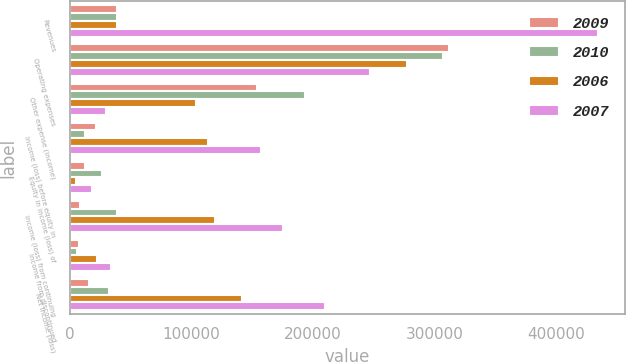<chart> <loc_0><loc_0><loc_500><loc_500><stacked_bar_chart><ecel><fcel>Revenues<fcel>Operating expenses<fcel>Other expense (income)<fcel>Income (loss) before equity in<fcel>Equity in income (loss) of<fcel>Income (loss) from continuing<fcel>Income from discontinued<fcel>Net income (loss)<nl><fcel>2009<fcel>38917<fcel>311622<fcel>153733<fcel>21451<fcel>12884<fcel>8567<fcel>7632<fcel>16199<nl><fcel>2010<fcel>38917<fcel>307138<fcel>193479<fcel>12544<fcel>26373<fcel>38917<fcel>6174<fcel>32743<nl><fcel>2006<fcel>38917<fcel>277095<fcel>103907<fcel>113932<fcel>5292<fcel>119224<fcel>22297<fcel>141521<nl><fcel>2007<fcel>434737<fcel>246924<fcel>30174<fcel>157639<fcel>18093<fcel>175732<fcel>34284<fcel>210016<nl></chart> 